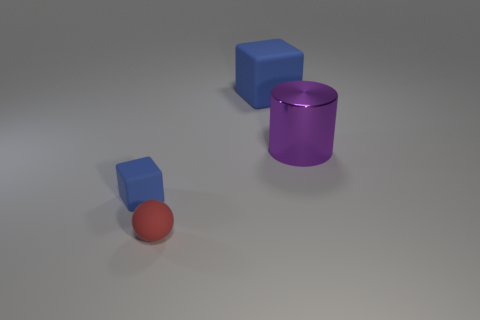Add 4 tiny blue blocks. How many objects exist? 8 Subtract all spheres. How many objects are left? 3 Subtract all large purple metallic balls. Subtract all matte objects. How many objects are left? 1 Add 2 rubber spheres. How many rubber spheres are left? 3 Add 4 large blue objects. How many large blue objects exist? 5 Subtract 1 red spheres. How many objects are left? 3 